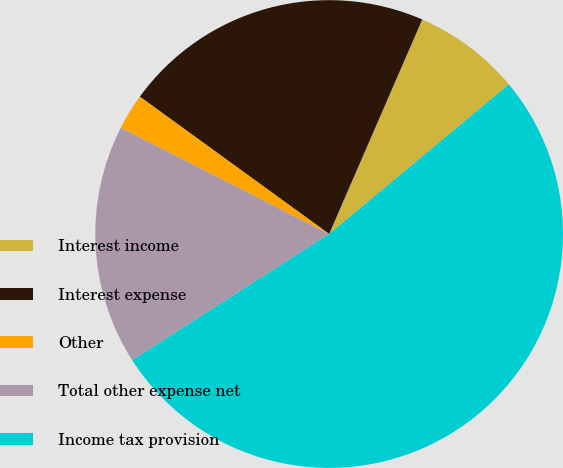<chart> <loc_0><loc_0><loc_500><loc_500><pie_chart><fcel>Interest income<fcel>Interest expense<fcel>Other<fcel>Total other expense net<fcel>Income tax provision<nl><fcel>7.43%<fcel>21.53%<fcel>2.48%<fcel>16.58%<fcel>51.98%<nl></chart> 